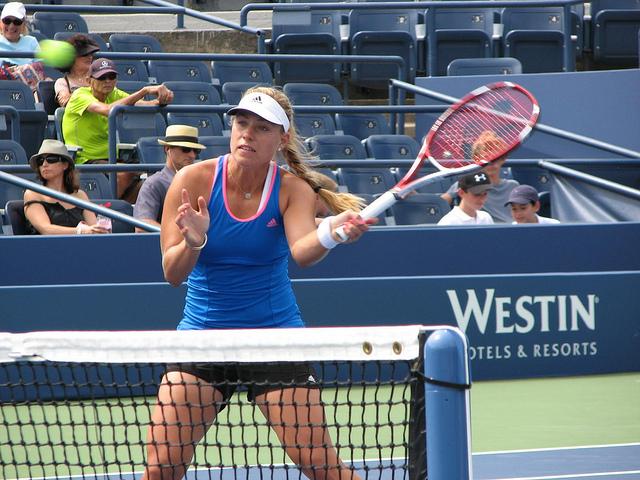Please identify all text content in this image. WESTIN OTELS RESORTS &amp; 1 